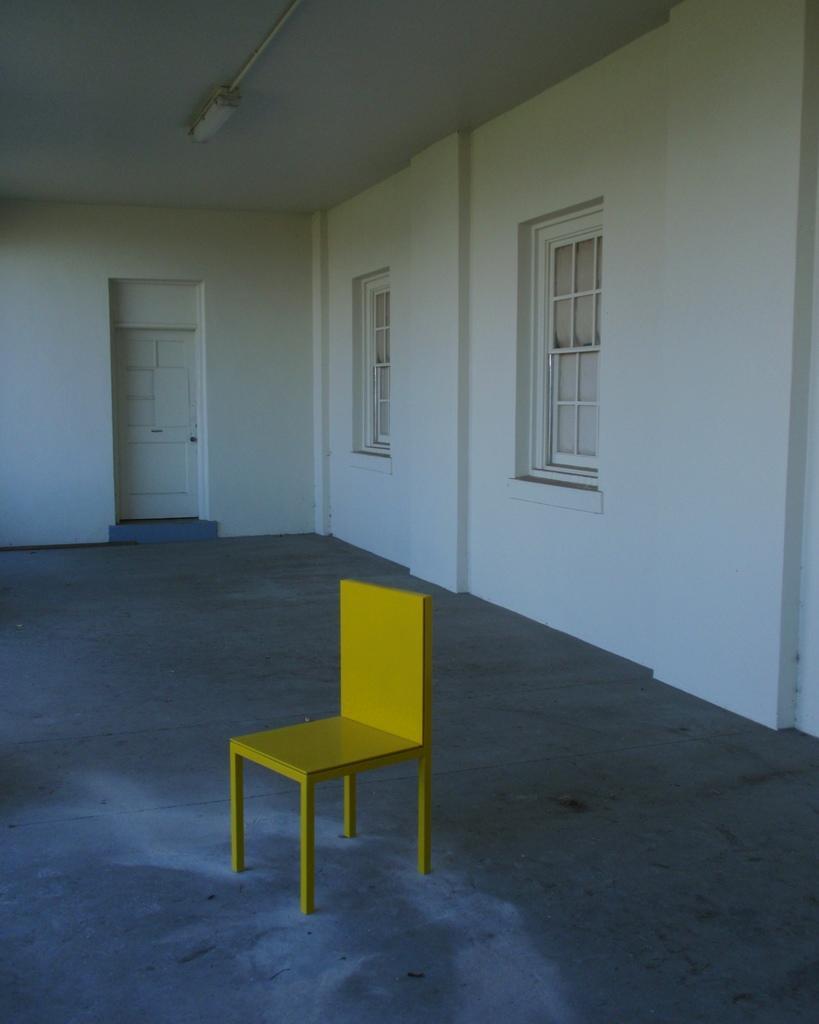Can you describe this image briefly? In the foreground I can see a chair on the floor. In the background I can see a wall, door and windows. On the top I can see a light. This image is taken in a hall. 